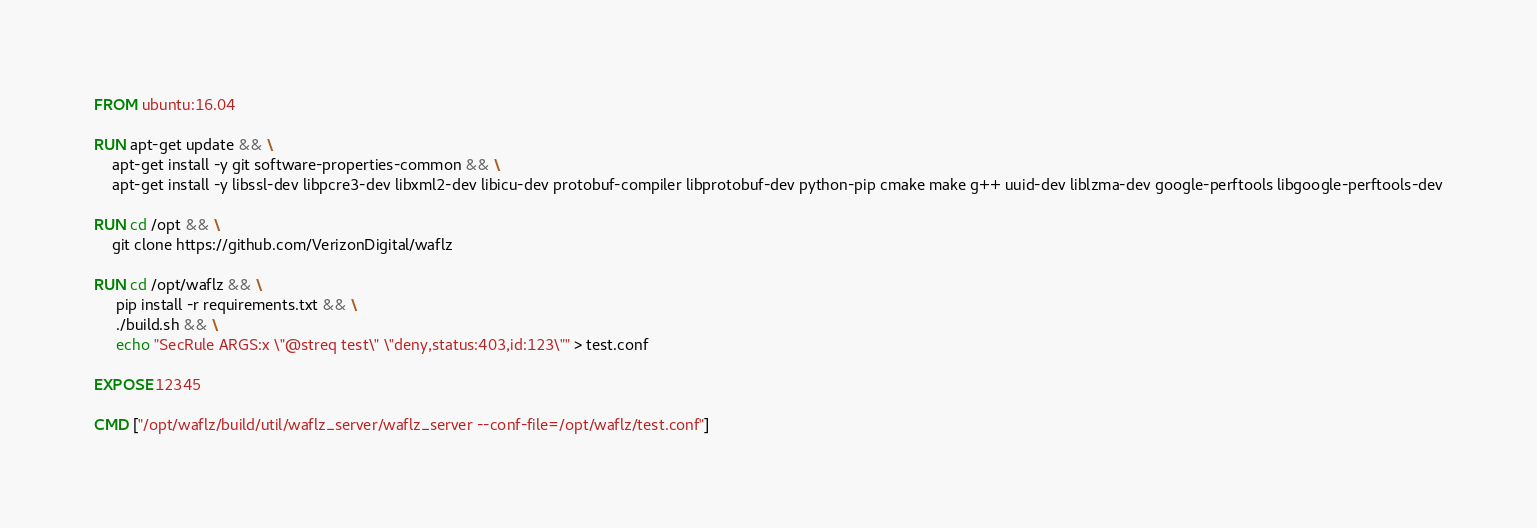Convert code to text. <code><loc_0><loc_0><loc_500><loc_500><_Dockerfile_>FROM ubuntu:16.04

RUN apt-get update && \
    apt-get install -y git software-properties-common && \
    apt-get install -y libssl-dev libpcre3-dev libxml2-dev libicu-dev protobuf-compiler libprotobuf-dev python-pip cmake make g++ uuid-dev liblzma-dev google-perftools libgoogle-perftools-dev

RUN cd /opt && \
    git clone https://github.com/VerizonDigital/waflz

RUN cd /opt/waflz && \
     pip install -r requirements.txt && \
     ./build.sh && \
     echo "SecRule ARGS:x \"@streq test\" \"deny,status:403,id:123\"" > test.conf

EXPOSE 12345

CMD ["/opt/waflz/build/util/waflz_server/waflz_server --conf-file=/opt/waflz/test.conf"]
</code> 